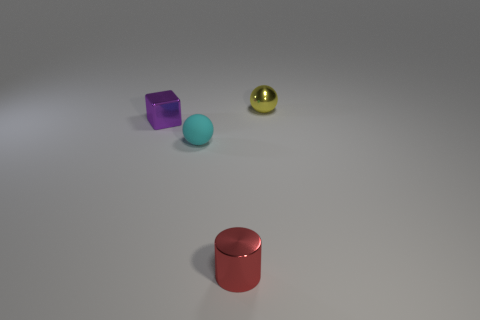Add 1 cylinders. How many objects exist? 5 Subtract all cylinders. How many objects are left? 3 Subtract all gray metallic spheres. Subtract all metallic things. How many objects are left? 1 Add 1 tiny red objects. How many tiny red objects are left? 2 Add 1 tiny cyan rubber things. How many tiny cyan rubber things exist? 2 Subtract 1 purple cubes. How many objects are left? 3 